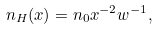<formula> <loc_0><loc_0><loc_500><loc_500>n _ { H } ( x ) = n _ { 0 } x ^ { - 2 } w ^ { - 1 } ,</formula> 